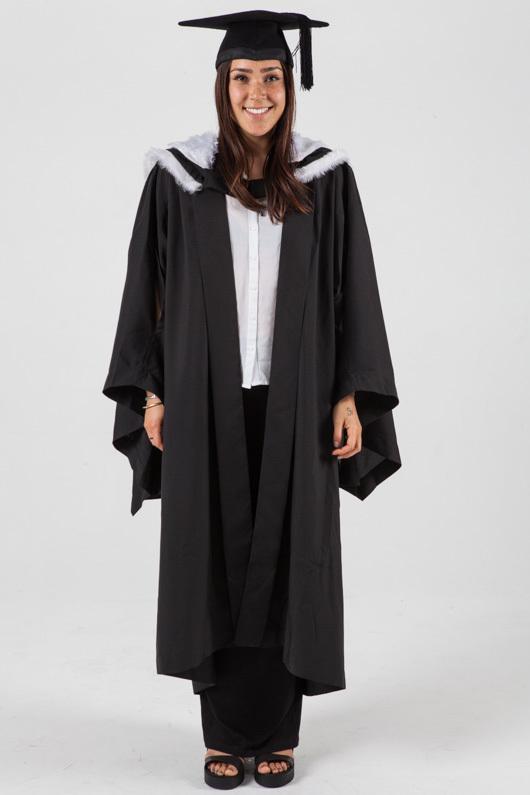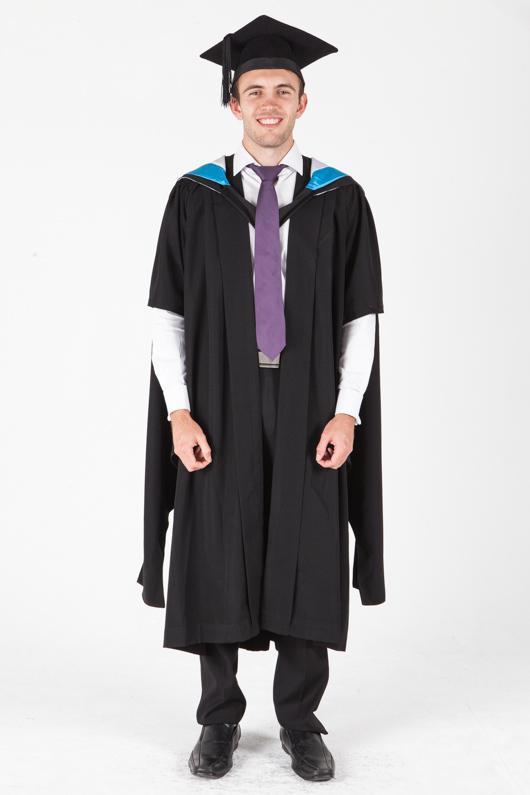The first image is the image on the left, the second image is the image on the right. Considering the images on both sides, is "Each graduate model wears a black robe and a square-topped black hat with black tassel, but one model is a dark-haired girl and the other is a young man wearing a purple necktie." valid? Answer yes or no. Yes. The first image is the image on the left, the second image is the image on the right. Evaluate the accuracy of this statement regarding the images: "The graduate attire in both images incorporate shades of red.". Is it true? Answer yes or no. No. 